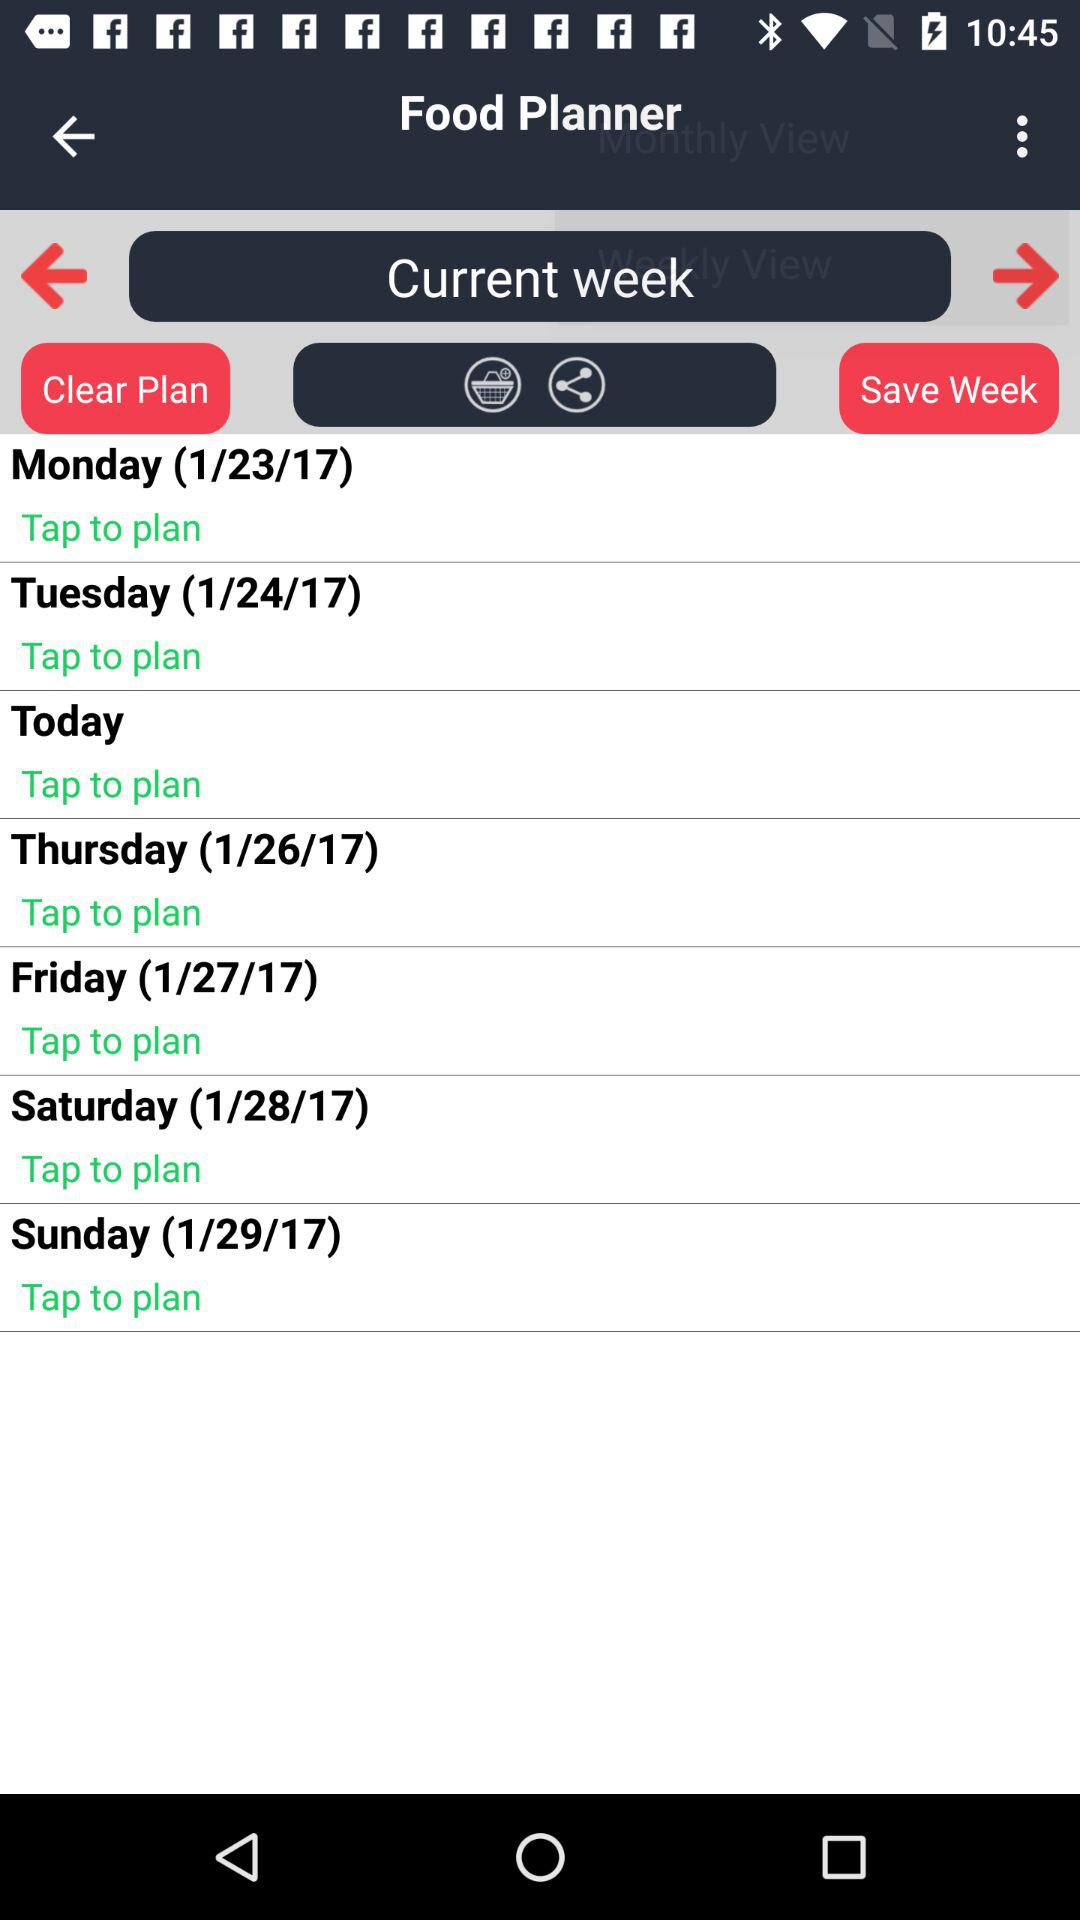What is the name of the application? The name of the application is "Food Planner". 